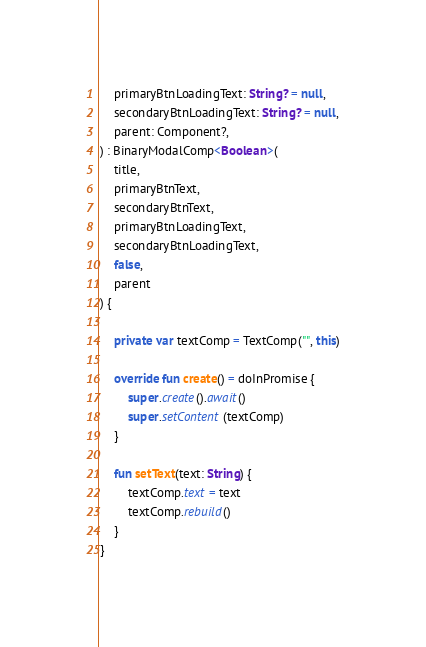Convert code to text. <code><loc_0><loc_0><loc_500><loc_500><_Kotlin_>    primaryBtnLoadingText: String? = null,
    secondaryBtnLoadingText: String? = null,
    parent: Component?,
) : BinaryModalComp<Boolean>(
    title,
    primaryBtnText,
    secondaryBtnText,
    primaryBtnLoadingText,
    secondaryBtnLoadingText,
    false,
    parent
) {

    private var textComp = TextComp("", this)

    override fun create() = doInPromise {
        super.create().await()
        super.setContent(textComp)
    }

    fun setText(text: String) {
        textComp.text = text
        textComp.rebuild()
    }
}
</code> 